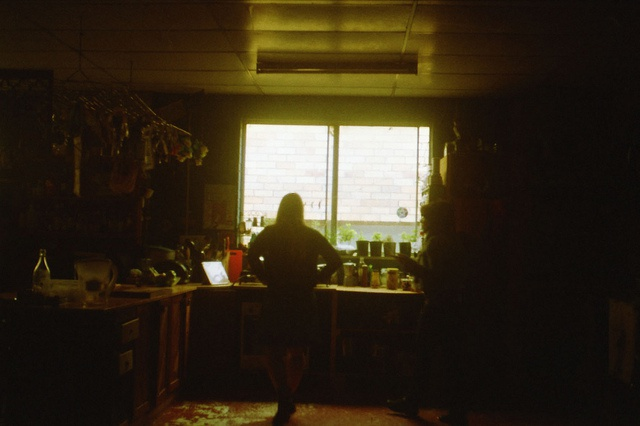Describe the objects in this image and their specific colors. I can see people in black and olive tones, people in black and olive tones, bottle in black and olive tones, bowl in black and olive tones, and potted plant in black, darkgreen, and olive tones in this image. 